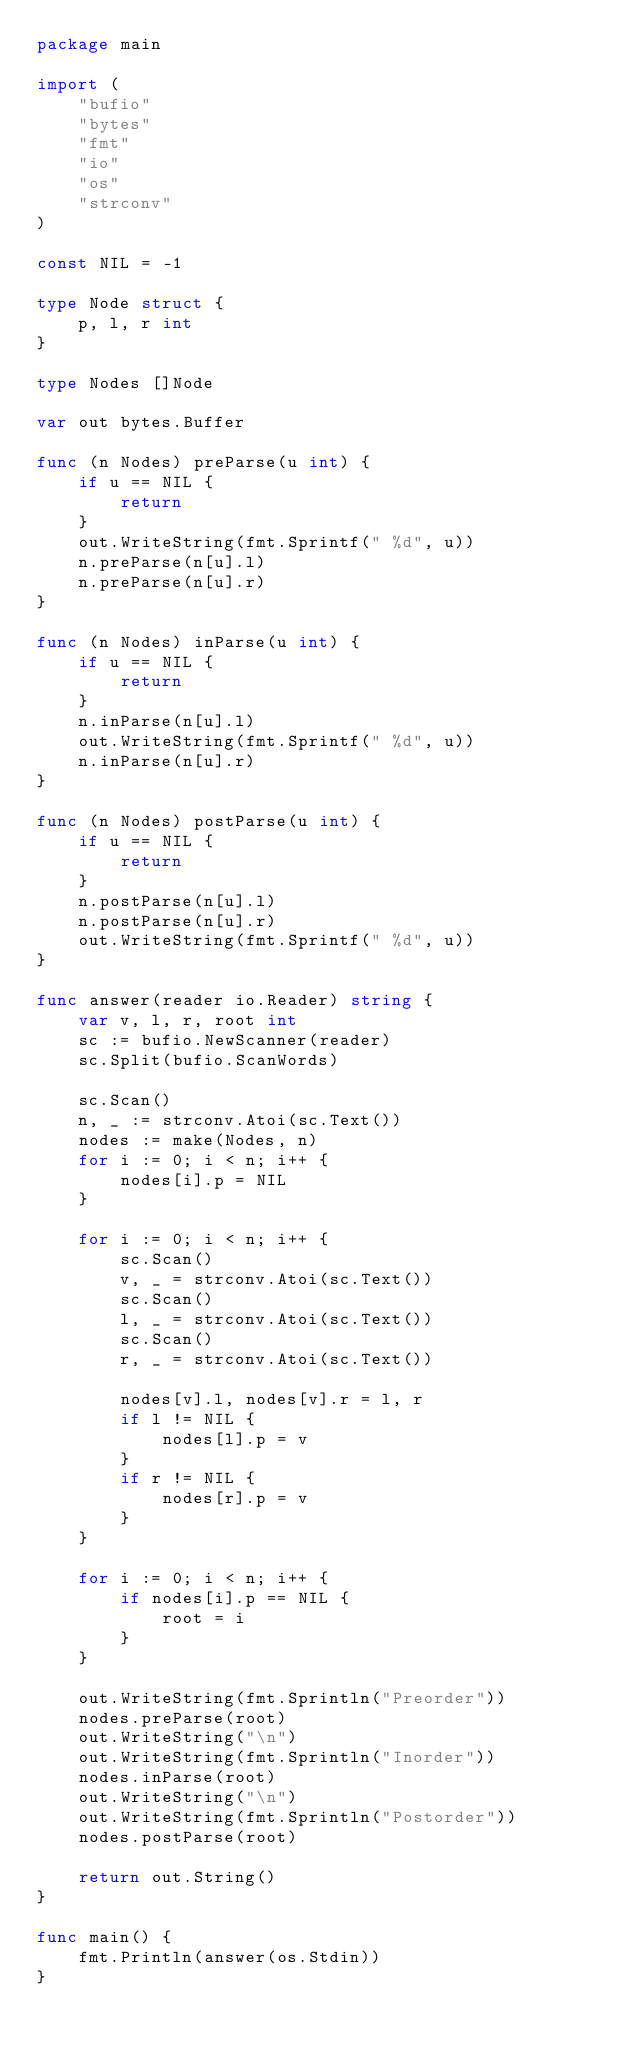Convert code to text. <code><loc_0><loc_0><loc_500><loc_500><_Go_>package main

import (
	"bufio"
	"bytes"
	"fmt"
	"io"
	"os"
	"strconv"
)

const NIL = -1

type Node struct {
	p, l, r int
}

type Nodes []Node

var out bytes.Buffer

func (n Nodes) preParse(u int) {
	if u == NIL {
		return
	}
	out.WriteString(fmt.Sprintf(" %d", u))
	n.preParse(n[u].l)
	n.preParse(n[u].r)
}

func (n Nodes) inParse(u int) {
	if u == NIL {
		return
	}
	n.inParse(n[u].l)
	out.WriteString(fmt.Sprintf(" %d", u))
	n.inParse(n[u].r)
}

func (n Nodes) postParse(u int) {
	if u == NIL {
		return
	}
	n.postParse(n[u].l)
	n.postParse(n[u].r)
	out.WriteString(fmt.Sprintf(" %d", u))
}

func answer(reader io.Reader) string {
	var v, l, r, root int
	sc := bufio.NewScanner(reader)
	sc.Split(bufio.ScanWords)

	sc.Scan()
	n, _ := strconv.Atoi(sc.Text())
	nodes := make(Nodes, n)
	for i := 0; i < n; i++ {
		nodes[i].p = NIL
	}

	for i := 0; i < n; i++ {
		sc.Scan()
		v, _ = strconv.Atoi(sc.Text())
		sc.Scan()
		l, _ = strconv.Atoi(sc.Text())
		sc.Scan()
		r, _ = strconv.Atoi(sc.Text())

		nodes[v].l, nodes[v].r = l, r
		if l != NIL {
			nodes[l].p = v
		}
		if r != NIL {
			nodes[r].p = v
		}
	}

	for i := 0; i < n; i++ {
		if nodes[i].p == NIL {
			root = i
		}
	}

	out.WriteString(fmt.Sprintln("Preorder"))
	nodes.preParse(root)
	out.WriteString("\n")
	out.WriteString(fmt.Sprintln("Inorder"))
	nodes.inParse(root)
	out.WriteString("\n")
	out.WriteString(fmt.Sprintln("Postorder"))
	nodes.postParse(root)

	return out.String()
}

func main() {
	fmt.Println(answer(os.Stdin))
}

</code> 